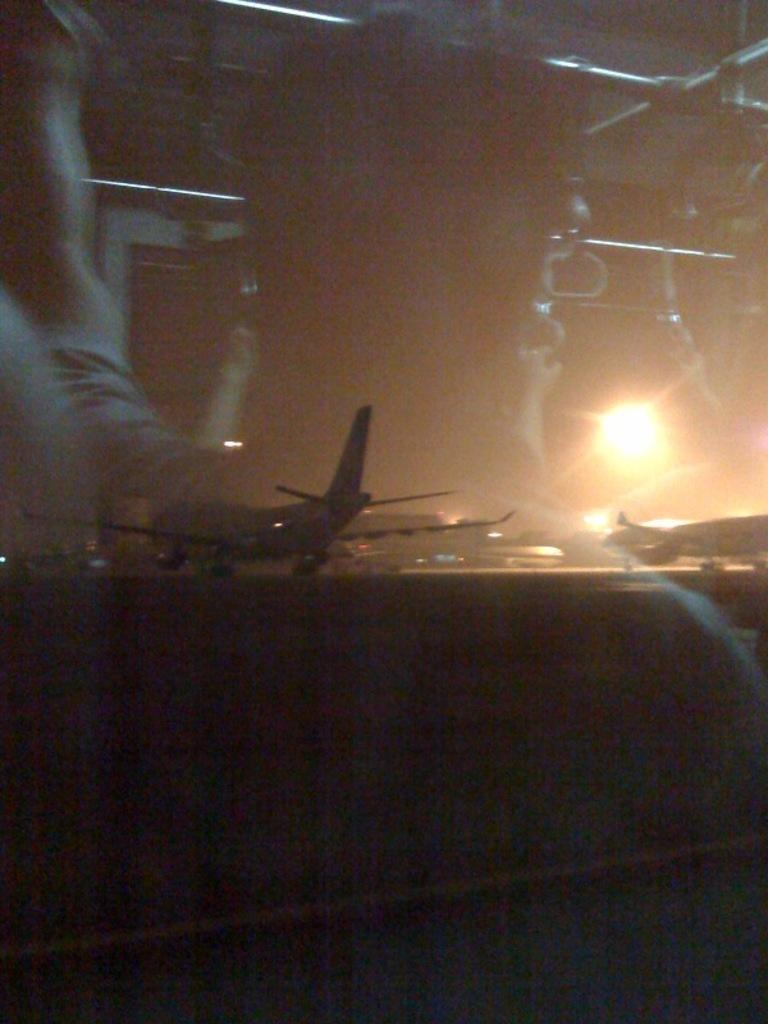What can be seen on the glass in the image? There are reflections of persons on the glass. What is visible beyond the glass? An aeroplane is visible through the glass. Can you describe the lighting in the image? There is light in the image. What type of animal can be seen on vacation in the image? There is no animal or vacation depicted in the image; it features reflections of persons on the glass and an aeroplane visible through the glass. 